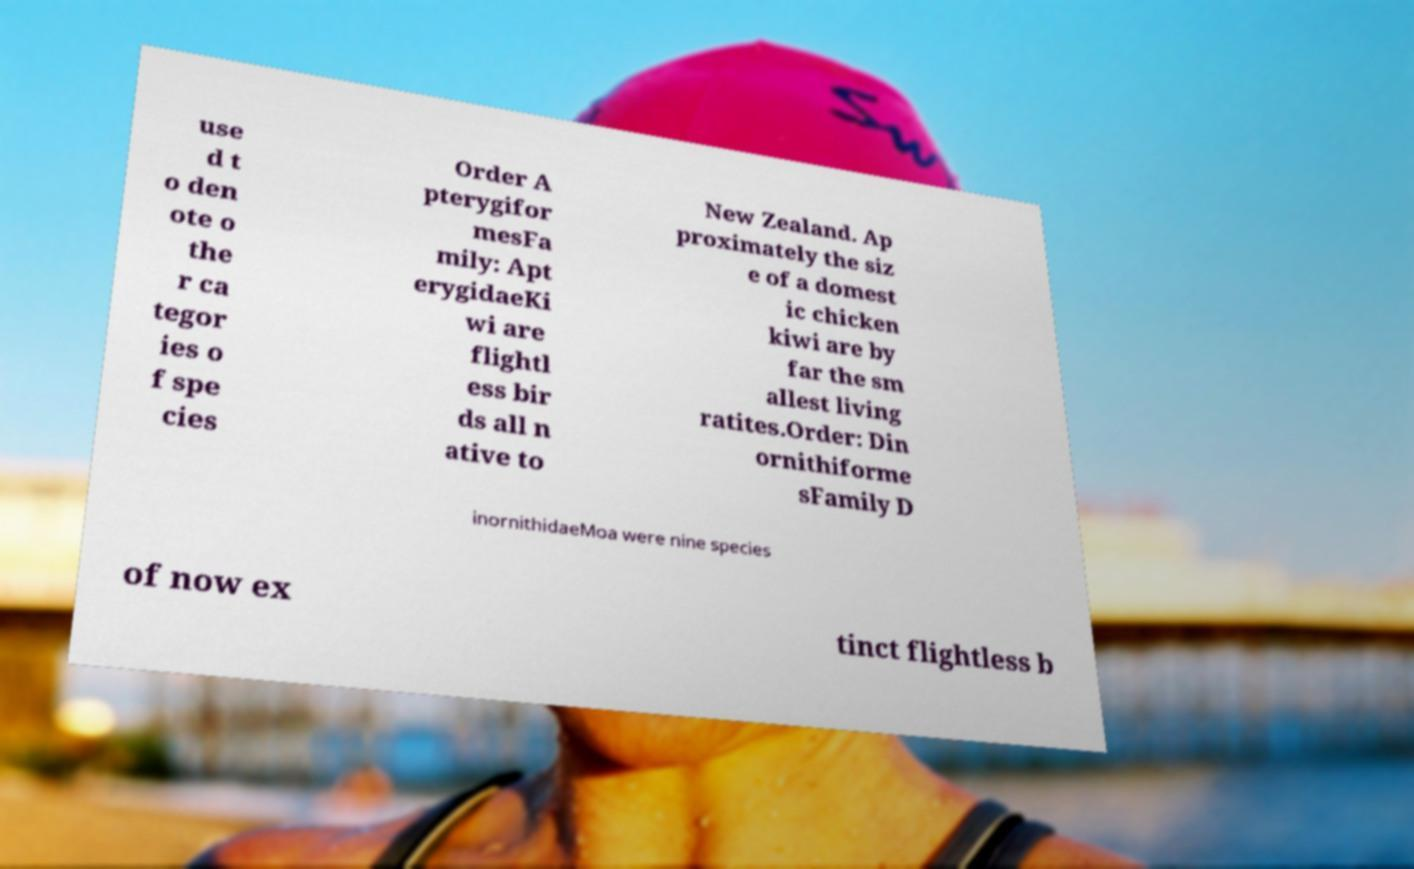Please identify and transcribe the text found in this image. use d t o den ote o the r ca tegor ies o f spe cies Order A pterygifor mesFa mily: Apt erygidaeKi wi are flightl ess bir ds all n ative to New Zealand. Ap proximately the siz e of a domest ic chicken kiwi are by far the sm allest living ratites.Order: Din ornithiforme sFamily D inornithidaeMoa were nine species of now ex tinct flightless b 